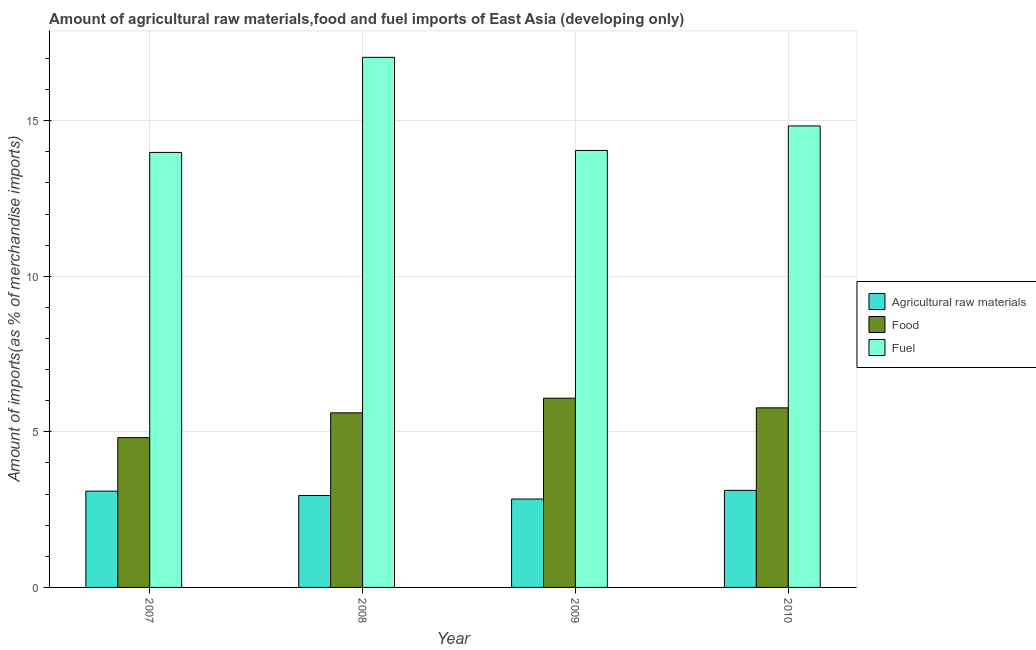How many different coloured bars are there?
Give a very brief answer. 3. Are the number of bars on each tick of the X-axis equal?
Ensure brevity in your answer.  Yes. What is the percentage of fuel imports in 2007?
Provide a succinct answer. 13.98. Across all years, what is the maximum percentage of raw materials imports?
Give a very brief answer. 3.12. Across all years, what is the minimum percentage of raw materials imports?
Your answer should be very brief. 2.84. In which year was the percentage of fuel imports minimum?
Provide a succinct answer. 2007. What is the total percentage of food imports in the graph?
Offer a very short reply. 22.28. What is the difference between the percentage of raw materials imports in 2007 and that in 2008?
Offer a very short reply. 0.14. What is the difference between the percentage of fuel imports in 2008 and the percentage of food imports in 2009?
Your answer should be very brief. 2.99. What is the average percentage of food imports per year?
Offer a terse response. 5.57. What is the ratio of the percentage of food imports in 2007 to that in 2010?
Your answer should be compact. 0.83. Is the percentage of raw materials imports in 2008 less than that in 2009?
Make the answer very short. No. Is the difference between the percentage of fuel imports in 2007 and 2008 greater than the difference between the percentage of food imports in 2007 and 2008?
Provide a short and direct response. No. What is the difference between the highest and the second highest percentage of fuel imports?
Ensure brevity in your answer.  2.21. What is the difference between the highest and the lowest percentage of food imports?
Your answer should be compact. 1.27. What does the 3rd bar from the left in 2010 represents?
Your answer should be compact. Fuel. What does the 3rd bar from the right in 2010 represents?
Ensure brevity in your answer.  Agricultural raw materials. What is the difference between two consecutive major ticks on the Y-axis?
Your answer should be very brief. 5. Does the graph contain grids?
Give a very brief answer. Yes. Where does the legend appear in the graph?
Your answer should be very brief. Center right. What is the title of the graph?
Your response must be concise. Amount of agricultural raw materials,food and fuel imports of East Asia (developing only). What is the label or title of the X-axis?
Make the answer very short. Year. What is the label or title of the Y-axis?
Your answer should be very brief. Amount of imports(as % of merchandise imports). What is the Amount of imports(as % of merchandise imports) in Agricultural raw materials in 2007?
Your answer should be compact. 3.09. What is the Amount of imports(as % of merchandise imports) of Food in 2007?
Your response must be concise. 4.81. What is the Amount of imports(as % of merchandise imports) of Fuel in 2007?
Offer a terse response. 13.98. What is the Amount of imports(as % of merchandise imports) in Agricultural raw materials in 2008?
Ensure brevity in your answer.  2.96. What is the Amount of imports(as % of merchandise imports) in Food in 2008?
Provide a succinct answer. 5.61. What is the Amount of imports(as % of merchandise imports) in Fuel in 2008?
Provide a short and direct response. 17.04. What is the Amount of imports(as % of merchandise imports) of Agricultural raw materials in 2009?
Offer a terse response. 2.84. What is the Amount of imports(as % of merchandise imports) of Food in 2009?
Offer a very short reply. 6.08. What is the Amount of imports(as % of merchandise imports) in Fuel in 2009?
Your answer should be very brief. 14.05. What is the Amount of imports(as % of merchandise imports) in Agricultural raw materials in 2010?
Provide a succinct answer. 3.12. What is the Amount of imports(as % of merchandise imports) in Food in 2010?
Make the answer very short. 5.77. What is the Amount of imports(as % of merchandise imports) in Fuel in 2010?
Ensure brevity in your answer.  14.83. Across all years, what is the maximum Amount of imports(as % of merchandise imports) of Agricultural raw materials?
Give a very brief answer. 3.12. Across all years, what is the maximum Amount of imports(as % of merchandise imports) of Food?
Ensure brevity in your answer.  6.08. Across all years, what is the maximum Amount of imports(as % of merchandise imports) in Fuel?
Your answer should be very brief. 17.04. Across all years, what is the minimum Amount of imports(as % of merchandise imports) of Agricultural raw materials?
Your answer should be compact. 2.84. Across all years, what is the minimum Amount of imports(as % of merchandise imports) of Food?
Provide a succinct answer. 4.81. Across all years, what is the minimum Amount of imports(as % of merchandise imports) of Fuel?
Provide a succinct answer. 13.98. What is the total Amount of imports(as % of merchandise imports) in Agricultural raw materials in the graph?
Offer a very short reply. 12.01. What is the total Amount of imports(as % of merchandise imports) of Food in the graph?
Make the answer very short. 22.28. What is the total Amount of imports(as % of merchandise imports) in Fuel in the graph?
Provide a succinct answer. 59.9. What is the difference between the Amount of imports(as % of merchandise imports) in Agricultural raw materials in 2007 and that in 2008?
Offer a very short reply. 0.14. What is the difference between the Amount of imports(as % of merchandise imports) of Food in 2007 and that in 2008?
Provide a short and direct response. -0.8. What is the difference between the Amount of imports(as % of merchandise imports) in Fuel in 2007 and that in 2008?
Ensure brevity in your answer.  -3.06. What is the difference between the Amount of imports(as % of merchandise imports) in Agricultural raw materials in 2007 and that in 2009?
Provide a short and direct response. 0.25. What is the difference between the Amount of imports(as % of merchandise imports) of Food in 2007 and that in 2009?
Provide a short and direct response. -1.27. What is the difference between the Amount of imports(as % of merchandise imports) in Fuel in 2007 and that in 2009?
Provide a succinct answer. -0.06. What is the difference between the Amount of imports(as % of merchandise imports) in Agricultural raw materials in 2007 and that in 2010?
Offer a terse response. -0.02. What is the difference between the Amount of imports(as % of merchandise imports) in Food in 2007 and that in 2010?
Make the answer very short. -0.96. What is the difference between the Amount of imports(as % of merchandise imports) of Fuel in 2007 and that in 2010?
Provide a short and direct response. -0.85. What is the difference between the Amount of imports(as % of merchandise imports) in Agricultural raw materials in 2008 and that in 2009?
Provide a short and direct response. 0.11. What is the difference between the Amount of imports(as % of merchandise imports) in Food in 2008 and that in 2009?
Your response must be concise. -0.47. What is the difference between the Amount of imports(as % of merchandise imports) in Fuel in 2008 and that in 2009?
Your answer should be compact. 2.99. What is the difference between the Amount of imports(as % of merchandise imports) of Agricultural raw materials in 2008 and that in 2010?
Provide a short and direct response. -0.16. What is the difference between the Amount of imports(as % of merchandise imports) of Food in 2008 and that in 2010?
Offer a terse response. -0.16. What is the difference between the Amount of imports(as % of merchandise imports) in Fuel in 2008 and that in 2010?
Your answer should be compact. 2.21. What is the difference between the Amount of imports(as % of merchandise imports) of Agricultural raw materials in 2009 and that in 2010?
Offer a very short reply. -0.28. What is the difference between the Amount of imports(as % of merchandise imports) in Food in 2009 and that in 2010?
Provide a short and direct response. 0.31. What is the difference between the Amount of imports(as % of merchandise imports) of Fuel in 2009 and that in 2010?
Give a very brief answer. -0.79. What is the difference between the Amount of imports(as % of merchandise imports) of Agricultural raw materials in 2007 and the Amount of imports(as % of merchandise imports) of Food in 2008?
Make the answer very short. -2.52. What is the difference between the Amount of imports(as % of merchandise imports) in Agricultural raw materials in 2007 and the Amount of imports(as % of merchandise imports) in Fuel in 2008?
Offer a very short reply. -13.94. What is the difference between the Amount of imports(as % of merchandise imports) in Food in 2007 and the Amount of imports(as % of merchandise imports) in Fuel in 2008?
Your answer should be compact. -12.22. What is the difference between the Amount of imports(as % of merchandise imports) of Agricultural raw materials in 2007 and the Amount of imports(as % of merchandise imports) of Food in 2009?
Your answer should be very brief. -2.99. What is the difference between the Amount of imports(as % of merchandise imports) of Agricultural raw materials in 2007 and the Amount of imports(as % of merchandise imports) of Fuel in 2009?
Your answer should be compact. -10.95. What is the difference between the Amount of imports(as % of merchandise imports) of Food in 2007 and the Amount of imports(as % of merchandise imports) of Fuel in 2009?
Give a very brief answer. -9.23. What is the difference between the Amount of imports(as % of merchandise imports) of Agricultural raw materials in 2007 and the Amount of imports(as % of merchandise imports) of Food in 2010?
Ensure brevity in your answer.  -2.68. What is the difference between the Amount of imports(as % of merchandise imports) in Agricultural raw materials in 2007 and the Amount of imports(as % of merchandise imports) in Fuel in 2010?
Keep it short and to the point. -11.74. What is the difference between the Amount of imports(as % of merchandise imports) of Food in 2007 and the Amount of imports(as % of merchandise imports) of Fuel in 2010?
Your answer should be very brief. -10.02. What is the difference between the Amount of imports(as % of merchandise imports) of Agricultural raw materials in 2008 and the Amount of imports(as % of merchandise imports) of Food in 2009?
Keep it short and to the point. -3.13. What is the difference between the Amount of imports(as % of merchandise imports) of Agricultural raw materials in 2008 and the Amount of imports(as % of merchandise imports) of Fuel in 2009?
Your answer should be compact. -11.09. What is the difference between the Amount of imports(as % of merchandise imports) in Food in 2008 and the Amount of imports(as % of merchandise imports) in Fuel in 2009?
Ensure brevity in your answer.  -8.43. What is the difference between the Amount of imports(as % of merchandise imports) in Agricultural raw materials in 2008 and the Amount of imports(as % of merchandise imports) in Food in 2010?
Provide a succinct answer. -2.82. What is the difference between the Amount of imports(as % of merchandise imports) in Agricultural raw materials in 2008 and the Amount of imports(as % of merchandise imports) in Fuel in 2010?
Provide a short and direct response. -11.88. What is the difference between the Amount of imports(as % of merchandise imports) of Food in 2008 and the Amount of imports(as % of merchandise imports) of Fuel in 2010?
Ensure brevity in your answer.  -9.22. What is the difference between the Amount of imports(as % of merchandise imports) in Agricultural raw materials in 2009 and the Amount of imports(as % of merchandise imports) in Food in 2010?
Your answer should be compact. -2.93. What is the difference between the Amount of imports(as % of merchandise imports) of Agricultural raw materials in 2009 and the Amount of imports(as % of merchandise imports) of Fuel in 2010?
Offer a very short reply. -11.99. What is the difference between the Amount of imports(as % of merchandise imports) of Food in 2009 and the Amount of imports(as % of merchandise imports) of Fuel in 2010?
Make the answer very short. -8.75. What is the average Amount of imports(as % of merchandise imports) in Agricultural raw materials per year?
Provide a succinct answer. 3. What is the average Amount of imports(as % of merchandise imports) in Food per year?
Give a very brief answer. 5.57. What is the average Amount of imports(as % of merchandise imports) of Fuel per year?
Your answer should be compact. 14.97. In the year 2007, what is the difference between the Amount of imports(as % of merchandise imports) in Agricultural raw materials and Amount of imports(as % of merchandise imports) in Food?
Offer a very short reply. -1.72. In the year 2007, what is the difference between the Amount of imports(as % of merchandise imports) of Agricultural raw materials and Amount of imports(as % of merchandise imports) of Fuel?
Provide a succinct answer. -10.89. In the year 2007, what is the difference between the Amount of imports(as % of merchandise imports) of Food and Amount of imports(as % of merchandise imports) of Fuel?
Your response must be concise. -9.17. In the year 2008, what is the difference between the Amount of imports(as % of merchandise imports) of Agricultural raw materials and Amount of imports(as % of merchandise imports) of Food?
Your answer should be compact. -2.66. In the year 2008, what is the difference between the Amount of imports(as % of merchandise imports) in Agricultural raw materials and Amount of imports(as % of merchandise imports) in Fuel?
Make the answer very short. -14.08. In the year 2008, what is the difference between the Amount of imports(as % of merchandise imports) in Food and Amount of imports(as % of merchandise imports) in Fuel?
Make the answer very short. -11.43. In the year 2009, what is the difference between the Amount of imports(as % of merchandise imports) in Agricultural raw materials and Amount of imports(as % of merchandise imports) in Food?
Your response must be concise. -3.24. In the year 2009, what is the difference between the Amount of imports(as % of merchandise imports) of Agricultural raw materials and Amount of imports(as % of merchandise imports) of Fuel?
Give a very brief answer. -11.2. In the year 2009, what is the difference between the Amount of imports(as % of merchandise imports) of Food and Amount of imports(as % of merchandise imports) of Fuel?
Give a very brief answer. -7.96. In the year 2010, what is the difference between the Amount of imports(as % of merchandise imports) in Agricultural raw materials and Amount of imports(as % of merchandise imports) in Food?
Offer a terse response. -2.65. In the year 2010, what is the difference between the Amount of imports(as % of merchandise imports) of Agricultural raw materials and Amount of imports(as % of merchandise imports) of Fuel?
Ensure brevity in your answer.  -11.71. In the year 2010, what is the difference between the Amount of imports(as % of merchandise imports) in Food and Amount of imports(as % of merchandise imports) in Fuel?
Your answer should be very brief. -9.06. What is the ratio of the Amount of imports(as % of merchandise imports) of Agricultural raw materials in 2007 to that in 2008?
Ensure brevity in your answer.  1.05. What is the ratio of the Amount of imports(as % of merchandise imports) of Food in 2007 to that in 2008?
Your answer should be very brief. 0.86. What is the ratio of the Amount of imports(as % of merchandise imports) of Fuel in 2007 to that in 2008?
Provide a short and direct response. 0.82. What is the ratio of the Amount of imports(as % of merchandise imports) in Agricultural raw materials in 2007 to that in 2009?
Provide a short and direct response. 1.09. What is the ratio of the Amount of imports(as % of merchandise imports) of Food in 2007 to that in 2009?
Make the answer very short. 0.79. What is the ratio of the Amount of imports(as % of merchandise imports) in Agricultural raw materials in 2007 to that in 2010?
Provide a short and direct response. 0.99. What is the ratio of the Amount of imports(as % of merchandise imports) of Food in 2007 to that in 2010?
Your answer should be compact. 0.83. What is the ratio of the Amount of imports(as % of merchandise imports) of Fuel in 2007 to that in 2010?
Make the answer very short. 0.94. What is the ratio of the Amount of imports(as % of merchandise imports) in Agricultural raw materials in 2008 to that in 2009?
Ensure brevity in your answer.  1.04. What is the ratio of the Amount of imports(as % of merchandise imports) in Food in 2008 to that in 2009?
Offer a terse response. 0.92. What is the ratio of the Amount of imports(as % of merchandise imports) in Fuel in 2008 to that in 2009?
Your answer should be very brief. 1.21. What is the ratio of the Amount of imports(as % of merchandise imports) in Agricultural raw materials in 2008 to that in 2010?
Make the answer very short. 0.95. What is the ratio of the Amount of imports(as % of merchandise imports) in Food in 2008 to that in 2010?
Make the answer very short. 0.97. What is the ratio of the Amount of imports(as % of merchandise imports) of Fuel in 2008 to that in 2010?
Your answer should be compact. 1.15. What is the ratio of the Amount of imports(as % of merchandise imports) of Agricultural raw materials in 2009 to that in 2010?
Your answer should be very brief. 0.91. What is the ratio of the Amount of imports(as % of merchandise imports) in Food in 2009 to that in 2010?
Keep it short and to the point. 1.05. What is the ratio of the Amount of imports(as % of merchandise imports) in Fuel in 2009 to that in 2010?
Give a very brief answer. 0.95. What is the difference between the highest and the second highest Amount of imports(as % of merchandise imports) of Agricultural raw materials?
Offer a terse response. 0.02. What is the difference between the highest and the second highest Amount of imports(as % of merchandise imports) in Food?
Keep it short and to the point. 0.31. What is the difference between the highest and the second highest Amount of imports(as % of merchandise imports) in Fuel?
Provide a short and direct response. 2.21. What is the difference between the highest and the lowest Amount of imports(as % of merchandise imports) of Agricultural raw materials?
Your answer should be compact. 0.28. What is the difference between the highest and the lowest Amount of imports(as % of merchandise imports) of Food?
Your response must be concise. 1.27. What is the difference between the highest and the lowest Amount of imports(as % of merchandise imports) in Fuel?
Your answer should be compact. 3.06. 